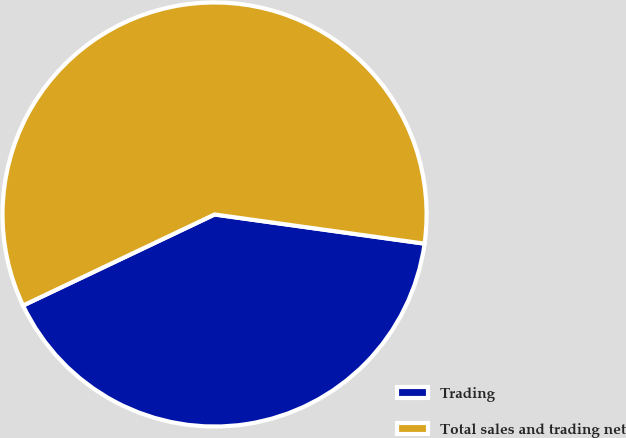<chart> <loc_0><loc_0><loc_500><loc_500><pie_chart><fcel>Trading<fcel>Total sales and trading net<nl><fcel>40.74%<fcel>59.26%<nl></chart> 